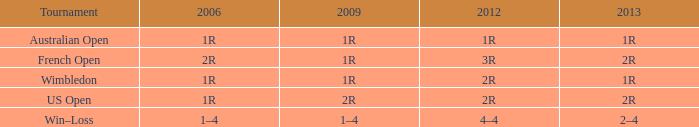What demonstrates for 2006, when 2013 is 2-4? 1–4. 